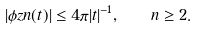Convert formula to latex. <formula><loc_0><loc_0><loc_500><loc_500>| \phi z n ( t ) | \leq 4 \pi | t | ^ { - 1 } , \quad n \geq 2 .</formula> 